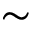<formula> <loc_0><loc_0><loc_500><loc_500>\sim</formula> 